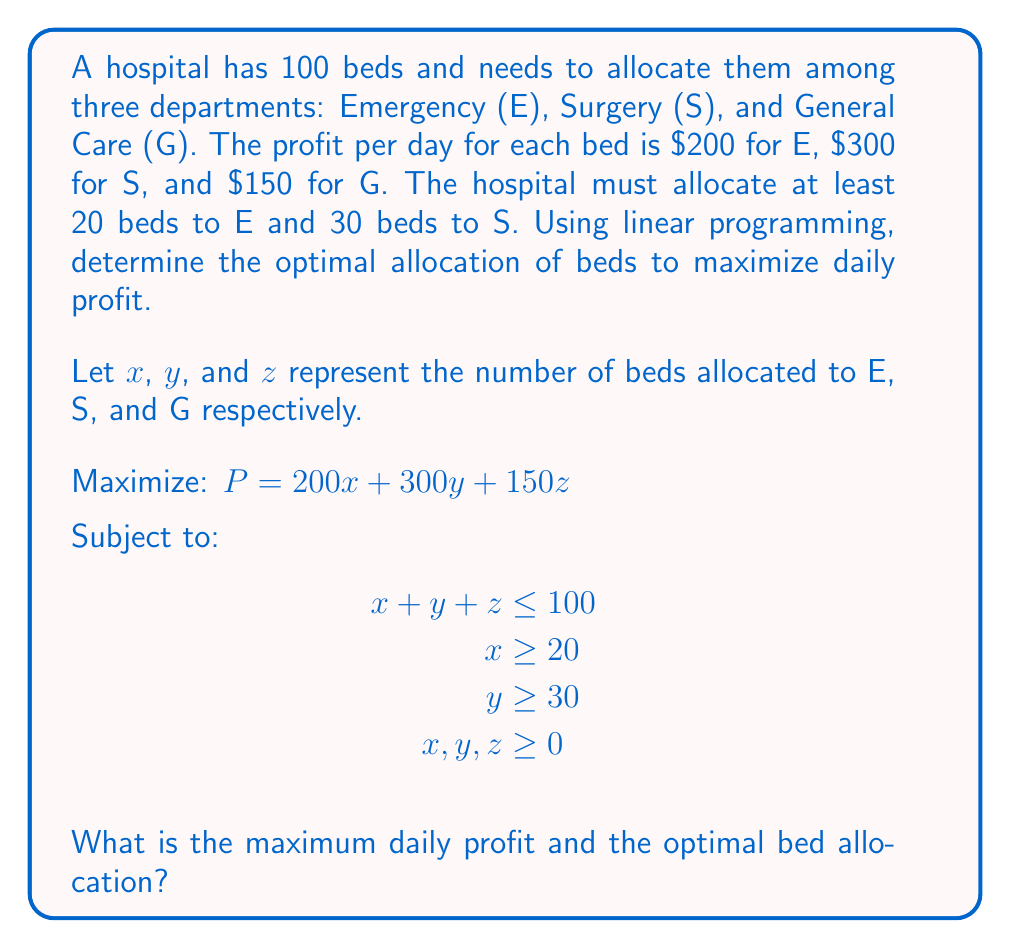Give your solution to this math problem. To solve this linear programming problem, we'll use the simplex method:

1) Convert inequalities to equalities by introducing slack variables:
   $x + y + z + s_1 = 100$
   $x - s_2 = 20$
   $y - s_3 = 30$

2) Initial tableau:
   $$
   \begin{array}{c|cccccccc}
    & x & y & z & s_1 & s_2 & s_3 & \text{RHS} \\
   \hline
   P & -200 & -300 & -150 & 0 & 0 & 0 & 0 \\
   s_1 & 1 & 1 & 1 & 1 & 0 & 0 & 100 \\
   x & 1 & 0 & 0 & 0 & -1 & 0 & 20 \\
   y & 0 & 1 & 0 & 0 & 0 & -1 & 30 \\
   \end{array}
   $$

3) Pivot on column y (most negative in objective row):
   $$
   \begin{array}{c|cccccccc}
    & x & y & z & s_1 & s_2 & s_3 & \text{RHS} \\
   \hline
   P & -200 & 0 & -150 & 0 & 0 & 300 & 9000 \\
   s_1 & 1 & 0 & 1 & 1 & 0 & 1 & 70 \\
   x & 1 & 0 & 0 & 0 & -1 & 0 & 20 \\
   y & 0 & 1 & 0 & 0 & 0 & -1 & 30 \\
   \end{array}
   $$

4) Pivot on column x:
   $$
   \begin{array}{c|cccccccc}
    & x & y & z & s_1 & s_2 & s_3 & \text{RHS} \\
   \hline
   P & 0 & 0 & -150 & 0 & 200 & 300 & 13000 \\
   s_1 & 0 & 0 & 1 & 1 & 1 & 1 & 50 \\
   x & 1 & 0 & 0 & 0 & -1 & 0 & 20 \\
   y & 0 & 1 & 0 & 0 & 0 & -1 & 30 \\
   \end{array}
   $$

5) Final pivot on column z:
   $$
   \begin{array}{c|cccccccc}
    & x & y & z & s_1 & s_2 & s_3 & \text{RHS} \\
   \hline
   P & 0 & 0 & 0 & 150 & 200 & 300 & 20500 \\
   z & 0 & 0 & 1 & 1 & 1 & 1 & 50 \\
   x & 1 & 0 & 0 & 0 & -1 & 0 & 20 \\
   y & 0 & 1 & 0 & 0 & 0 & -1 & 30 \\
   \end{array}
   $$

The optimal solution is:
x (Emergency) = 20 beds
y (Surgery) = 30 beds
z (General Care) = 50 beds
Maximum daily profit = $20,500
Answer: $20,500; E: 20, S: 30, G: 50 